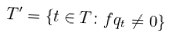<formula> <loc_0><loc_0><loc_500><loc_500>T ^ { \prime } = \{ t \in T \colon f q _ { t } \neq 0 \}</formula> 